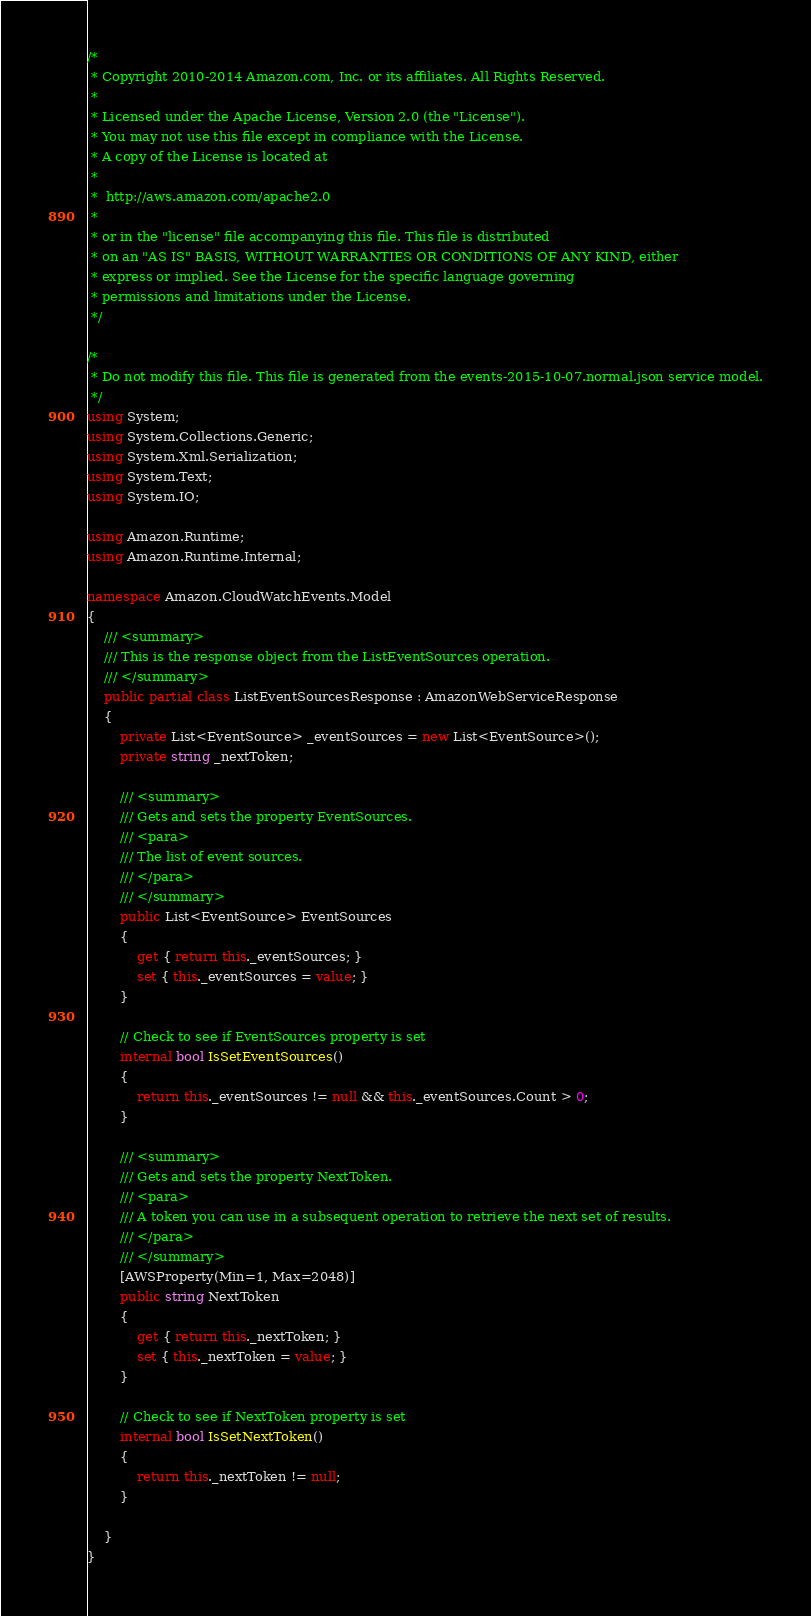<code> <loc_0><loc_0><loc_500><loc_500><_C#_>/*
 * Copyright 2010-2014 Amazon.com, Inc. or its affiliates. All Rights Reserved.
 * 
 * Licensed under the Apache License, Version 2.0 (the "License").
 * You may not use this file except in compliance with the License.
 * A copy of the License is located at
 * 
 *  http://aws.amazon.com/apache2.0
 * 
 * or in the "license" file accompanying this file. This file is distributed
 * on an "AS IS" BASIS, WITHOUT WARRANTIES OR CONDITIONS OF ANY KIND, either
 * express or implied. See the License for the specific language governing
 * permissions and limitations under the License.
 */

/*
 * Do not modify this file. This file is generated from the events-2015-10-07.normal.json service model.
 */
using System;
using System.Collections.Generic;
using System.Xml.Serialization;
using System.Text;
using System.IO;

using Amazon.Runtime;
using Amazon.Runtime.Internal;

namespace Amazon.CloudWatchEvents.Model
{
    /// <summary>
    /// This is the response object from the ListEventSources operation.
    /// </summary>
    public partial class ListEventSourcesResponse : AmazonWebServiceResponse
    {
        private List<EventSource> _eventSources = new List<EventSource>();
        private string _nextToken;

        /// <summary>
        /// Gets and sets the property EventSources. 
        /// <para>
        /// The list of event sources.
        /// </para>
        /// </summary>
        public List<EventSource> EventSources
        {
            get { return this._eventSources; }
            set { this._eventSources = value; }
        }

        // Check to see if EventSources property is set
        internal bool IsSetEventSources()
        {
            return this._eventSources != null && this._eventSources.Count > 0; 
        }

        /// <summary>
        /// Gets and sets the property NextToken. 
        /// <para>
        /// A token you can use in a subsequent operation to retrieve the next set of results.
        /// </para>
        /// </summary>
        [AWSProperty(Min=1, Max=2048)]
        public string NextToken
        {
            get { return this._nextToken; }
            set { this._nextToken = value; }
        }

        // Check to see if NextToken property is set
        internal bool IsSetNextToken()
        {
            return this._nextToken != null;
        }

    }
}</code> 